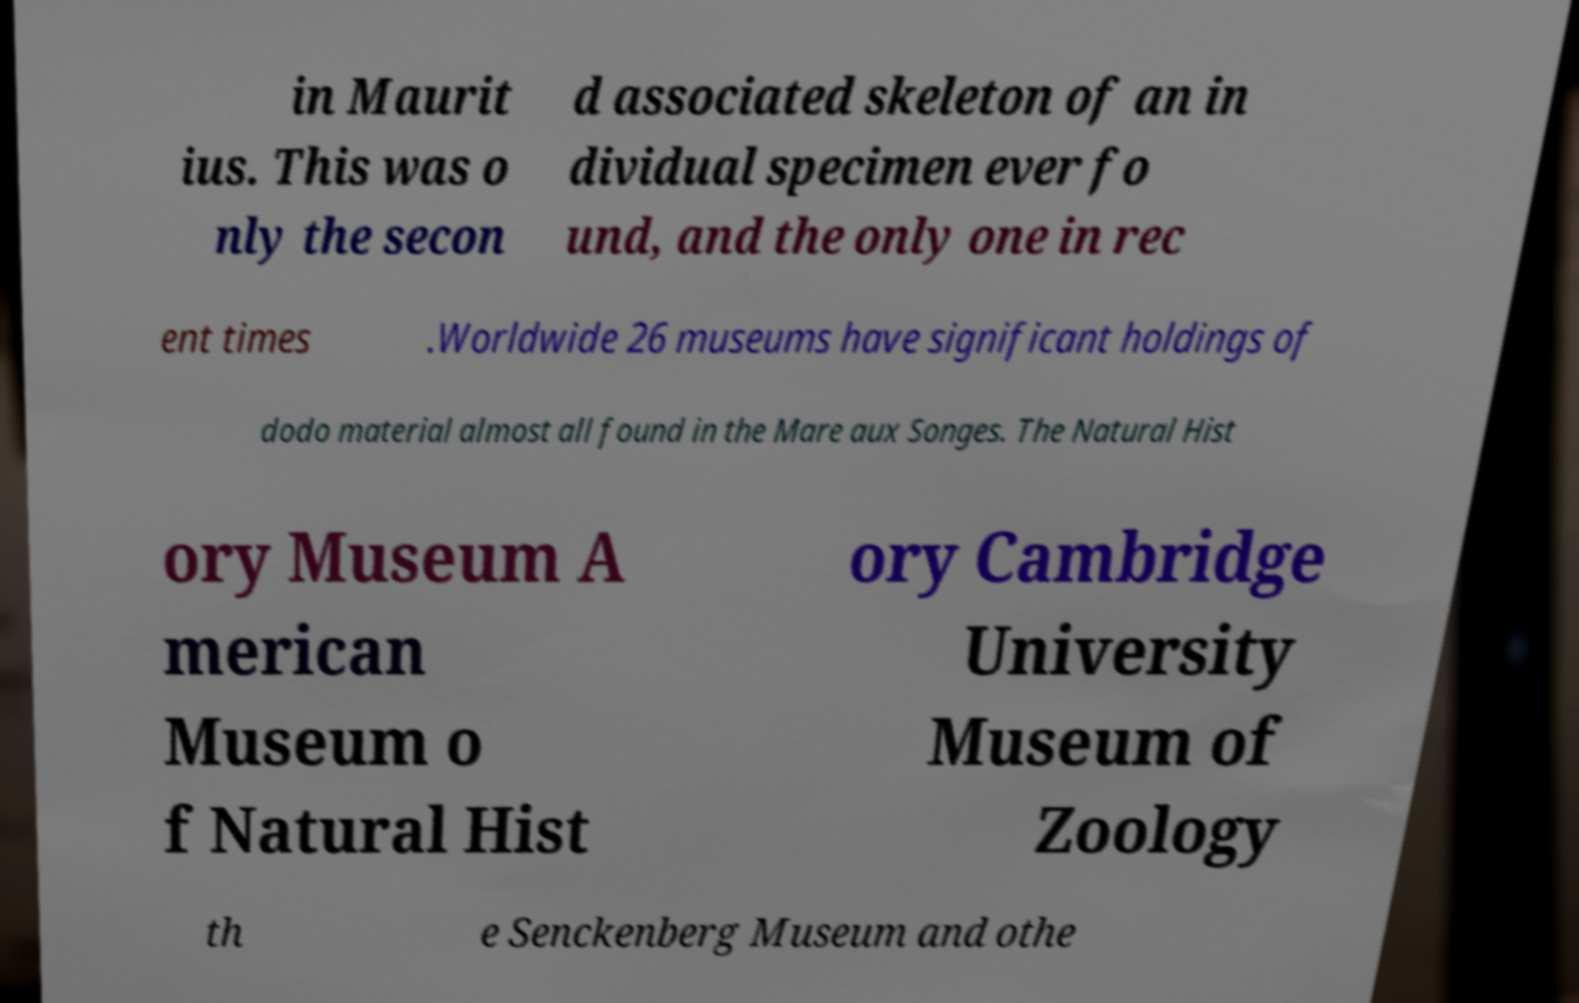There's text embedded in this image that I need extracted. Can you transcribe it verbatim? in Maurit ius. This was o nly the secon d associated skeleton of an in dividual specimen ever fo und, and the only one in rec ent times .Worldwide 26 museums have significant holdings of dodo material almost all found in the Mare aux Songes. The Natural Hist ory Museum A merican Museum o f Natural Hist ory Cambridge University Museum of Zoology th e Senckenberg Museum and othe 